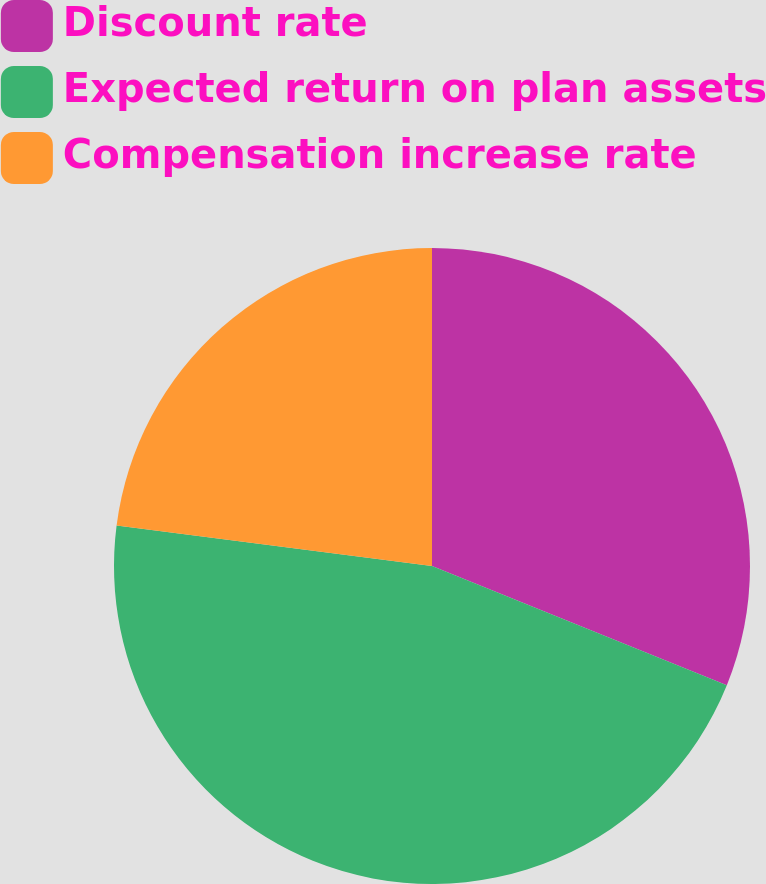Convert chart to OTSL. <chart><loc_0><loc_0><loc_500><loc_500><pie_chart><fcel>Discount rate<fcel>Expected return on plan assets<fcel>Compensation increase rate<nl><fcel>31.11%<fcel>45.92%<fcel>22.96%<nl></chart> 